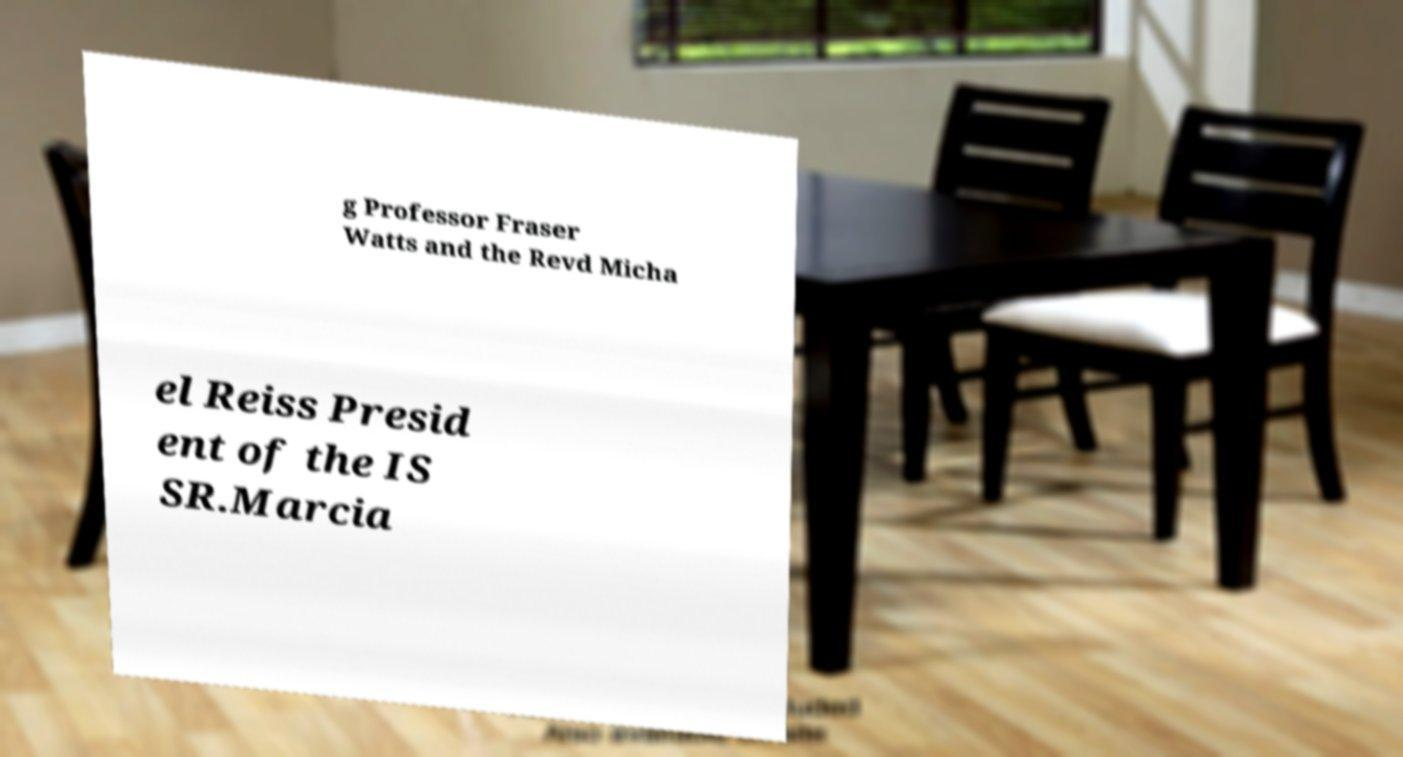Can you read and provide the text displayed in the image?This photo seems to have some interesting text. Can you extract and type it out for me? g Professor Fraser Watts and the Revd Micha el Reiss Presid ent of the IS SR.Marcia 